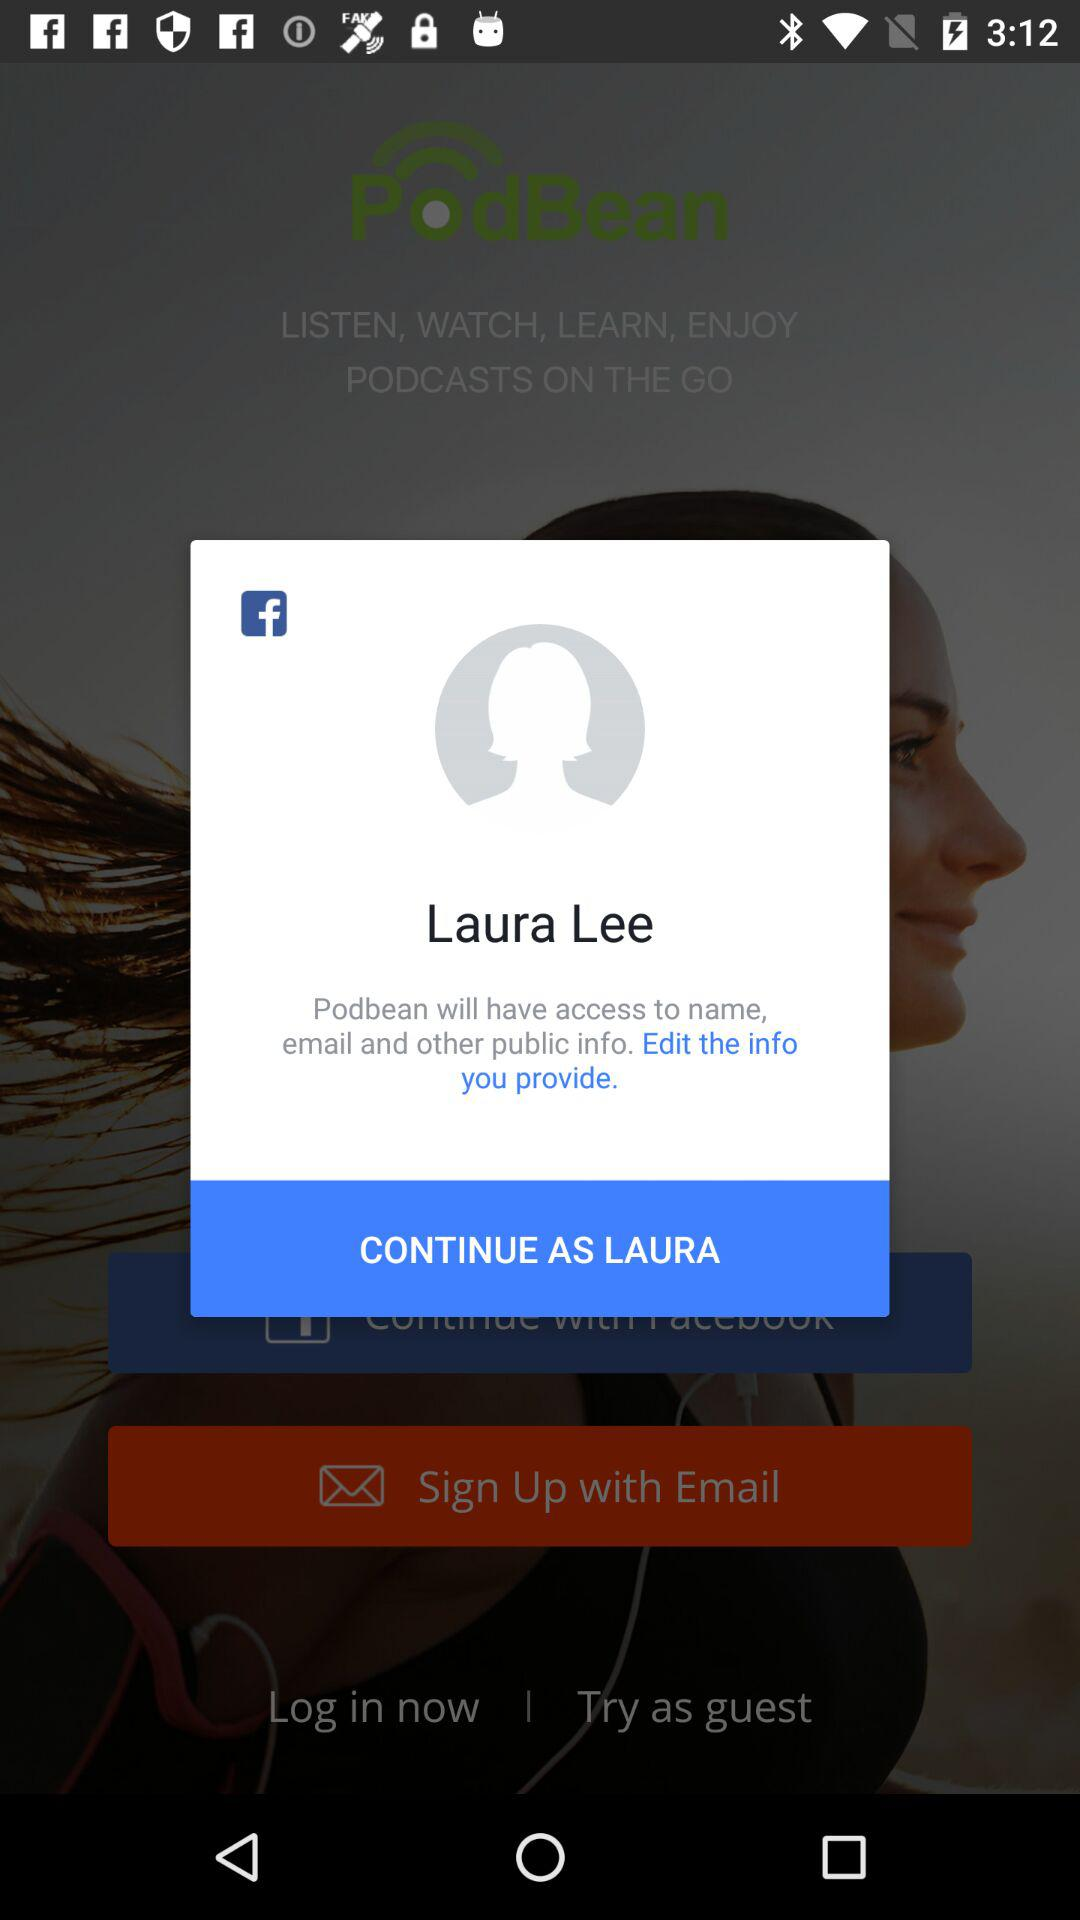What application is requesting access permission? The application is "Podbean". 